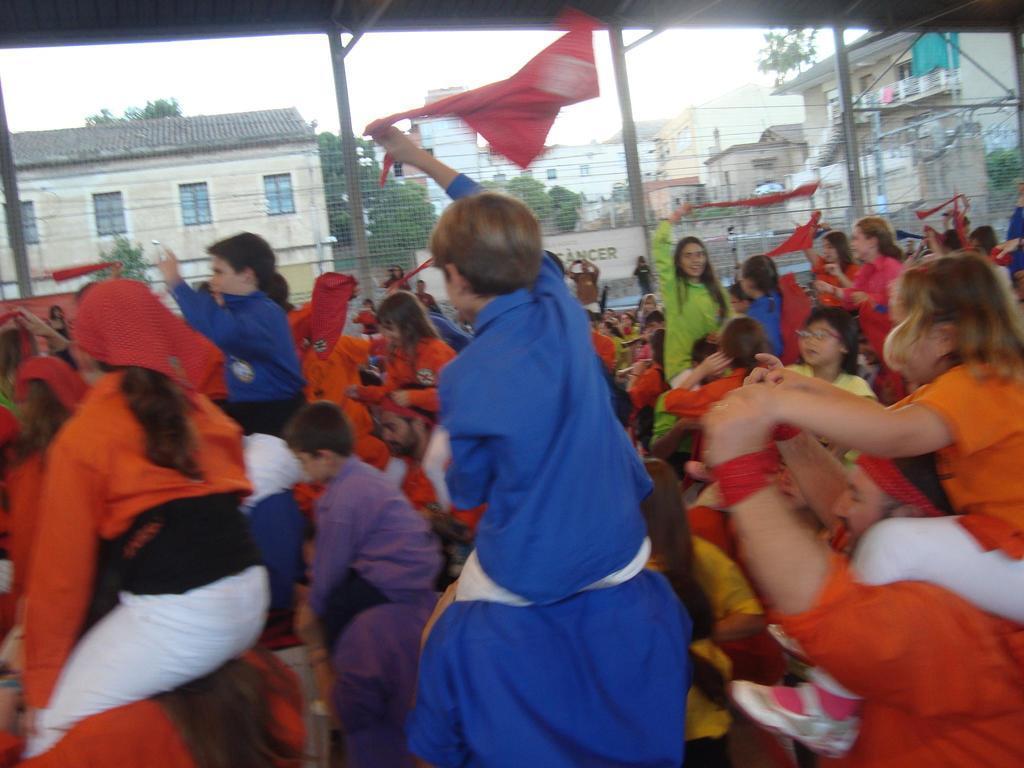Could you give a brief overview of what you see in this image? In this picture we can see many people with kids on their shoulders wearing colorful dresses. In the background, we can see houses and trees. 